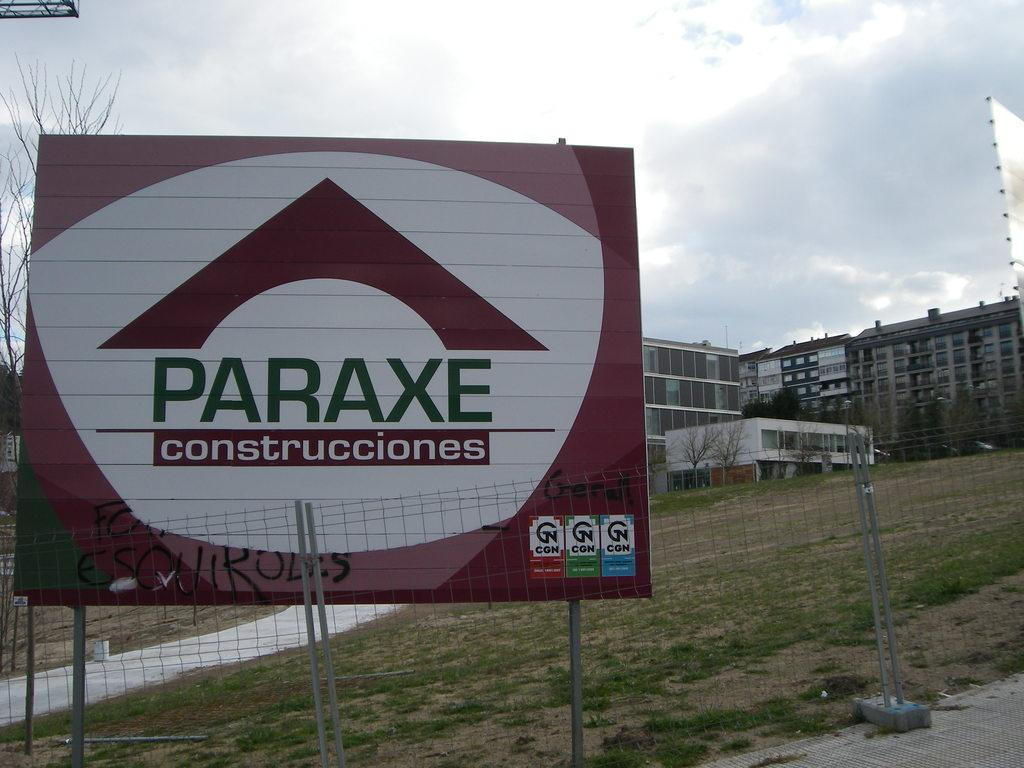<image>
Present a compact description of the photo's key features. A sign at the bottom of a small hill says Paraxe construcciones. 